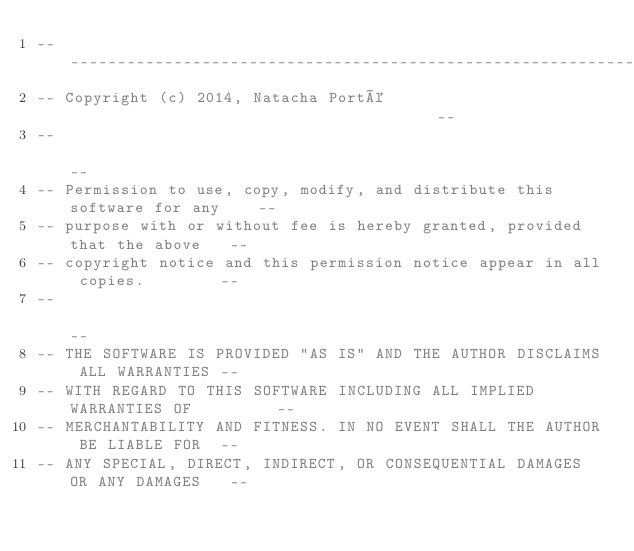Convert code to text. <code><loc_0><loc_0><loc_500><loc_500><_Ada_>------------------------------------------------------------------------------
-- Copyright (c) 2014, Natacha Porté                                        --
--                                                                          --
-- Permission to use, copy, modify, and distribute this software for any    --
-- purpose with or without fee is hereby granted, provided that the above   --
-- copyright notice and this permission notice appear in all copies.        --
--                                                                          --
-- THE SOFTWARE IS PROVIDED "AS IS" AND THE AUTHOR DISCLAIMS ALL WARRANTIES --
-- WITH REGARD TO THIS SOFTWARE INCLUDING ALL IMPLIED WARRANTIES OF         --
-- MERCHANTABILITY AND FITNESS. IN NO EVENT SHALL THE AUTHOR BE LIABLE FOR  --
-- ANY SPECIAL, DIRECT, INDIRECT, OR CONSEQUENTIAL DAMAGES OR ANY DAMAGES   --</code> 